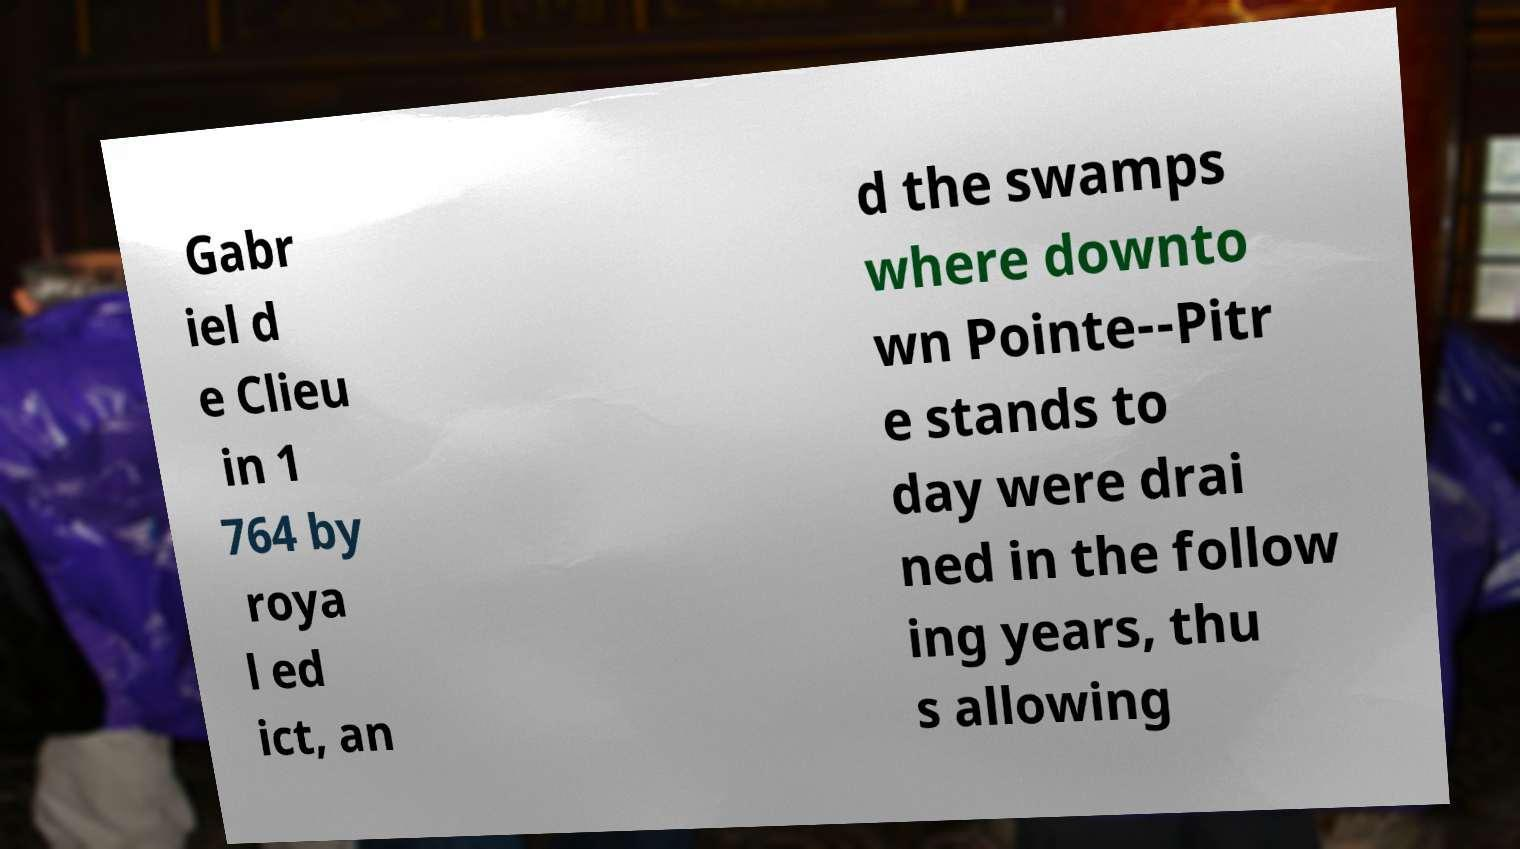What messages or text are displayed in this image? I need them in a readable, typed format. Gabr iel d e Clieu in 1 764 by roya l ed ict, an d the swamps where downto wn Pointe--Pitr e stands to day were drai ned in the follow ing years, thu s allowing 